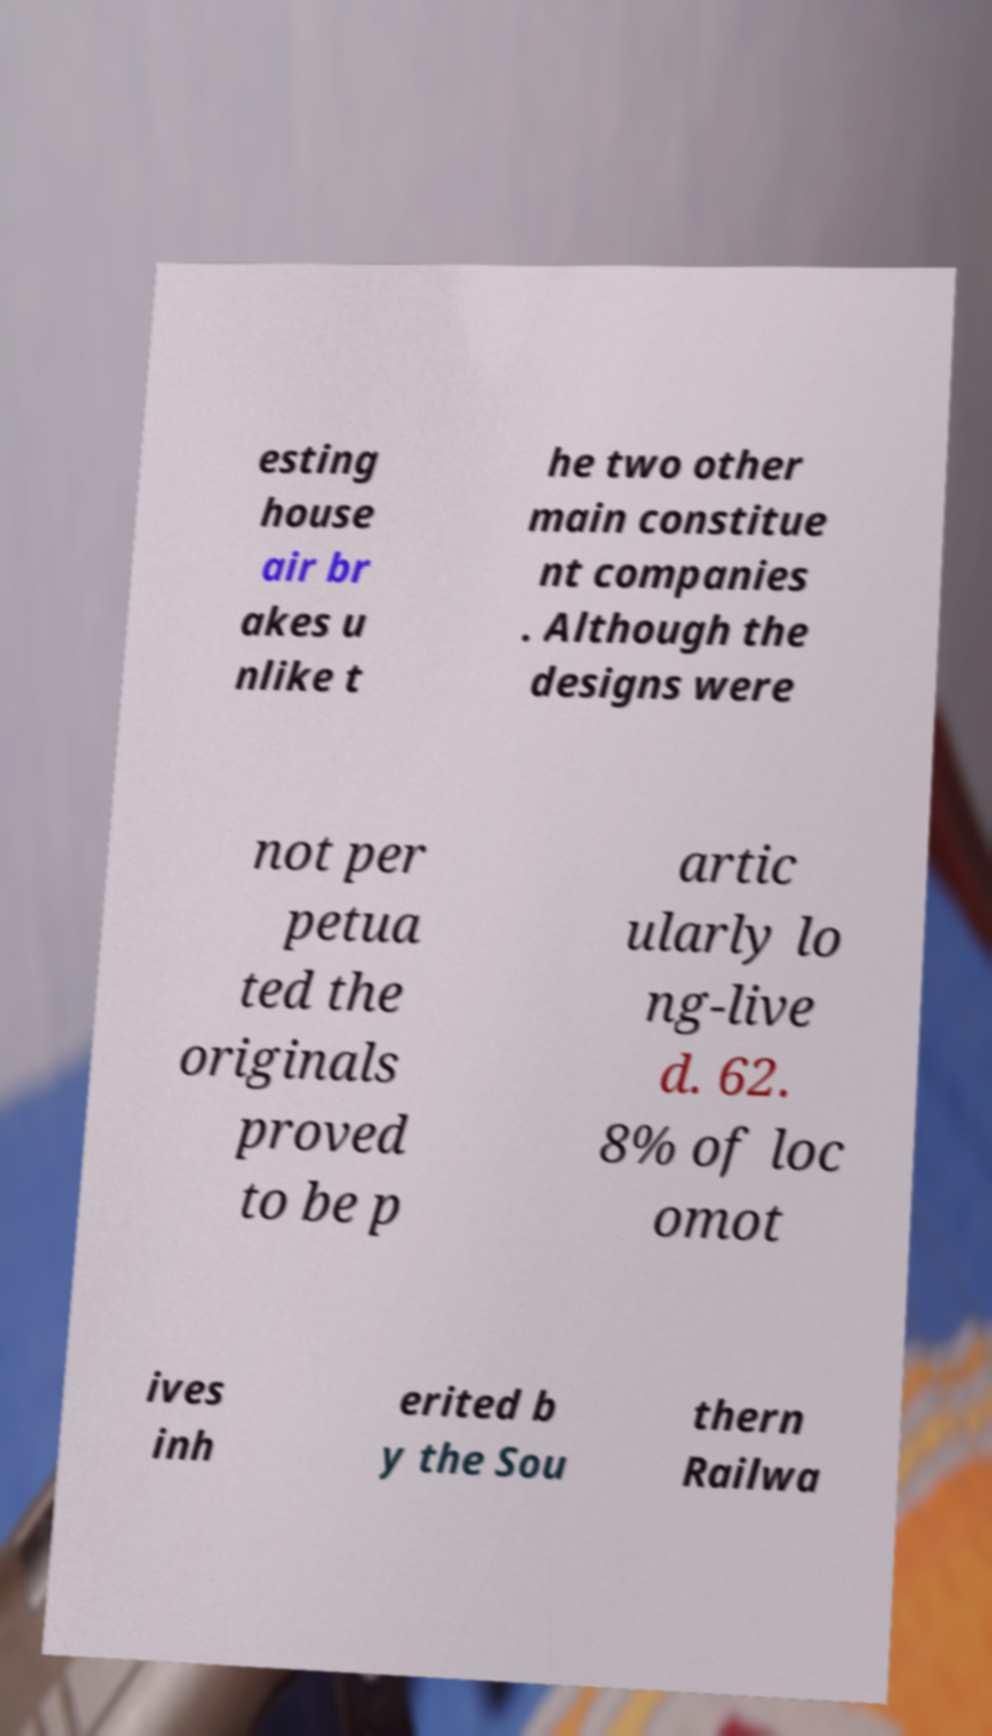Please identify and transcribe the text found in this image. esting house air br akes u nlike t he two other main constitue nt companies . Although the designs were not per petua ted the originals proved to be p artic ularly lo ng-live d. 62. 8% of loc omot ives inh erited b y the Sou thern Railwa 